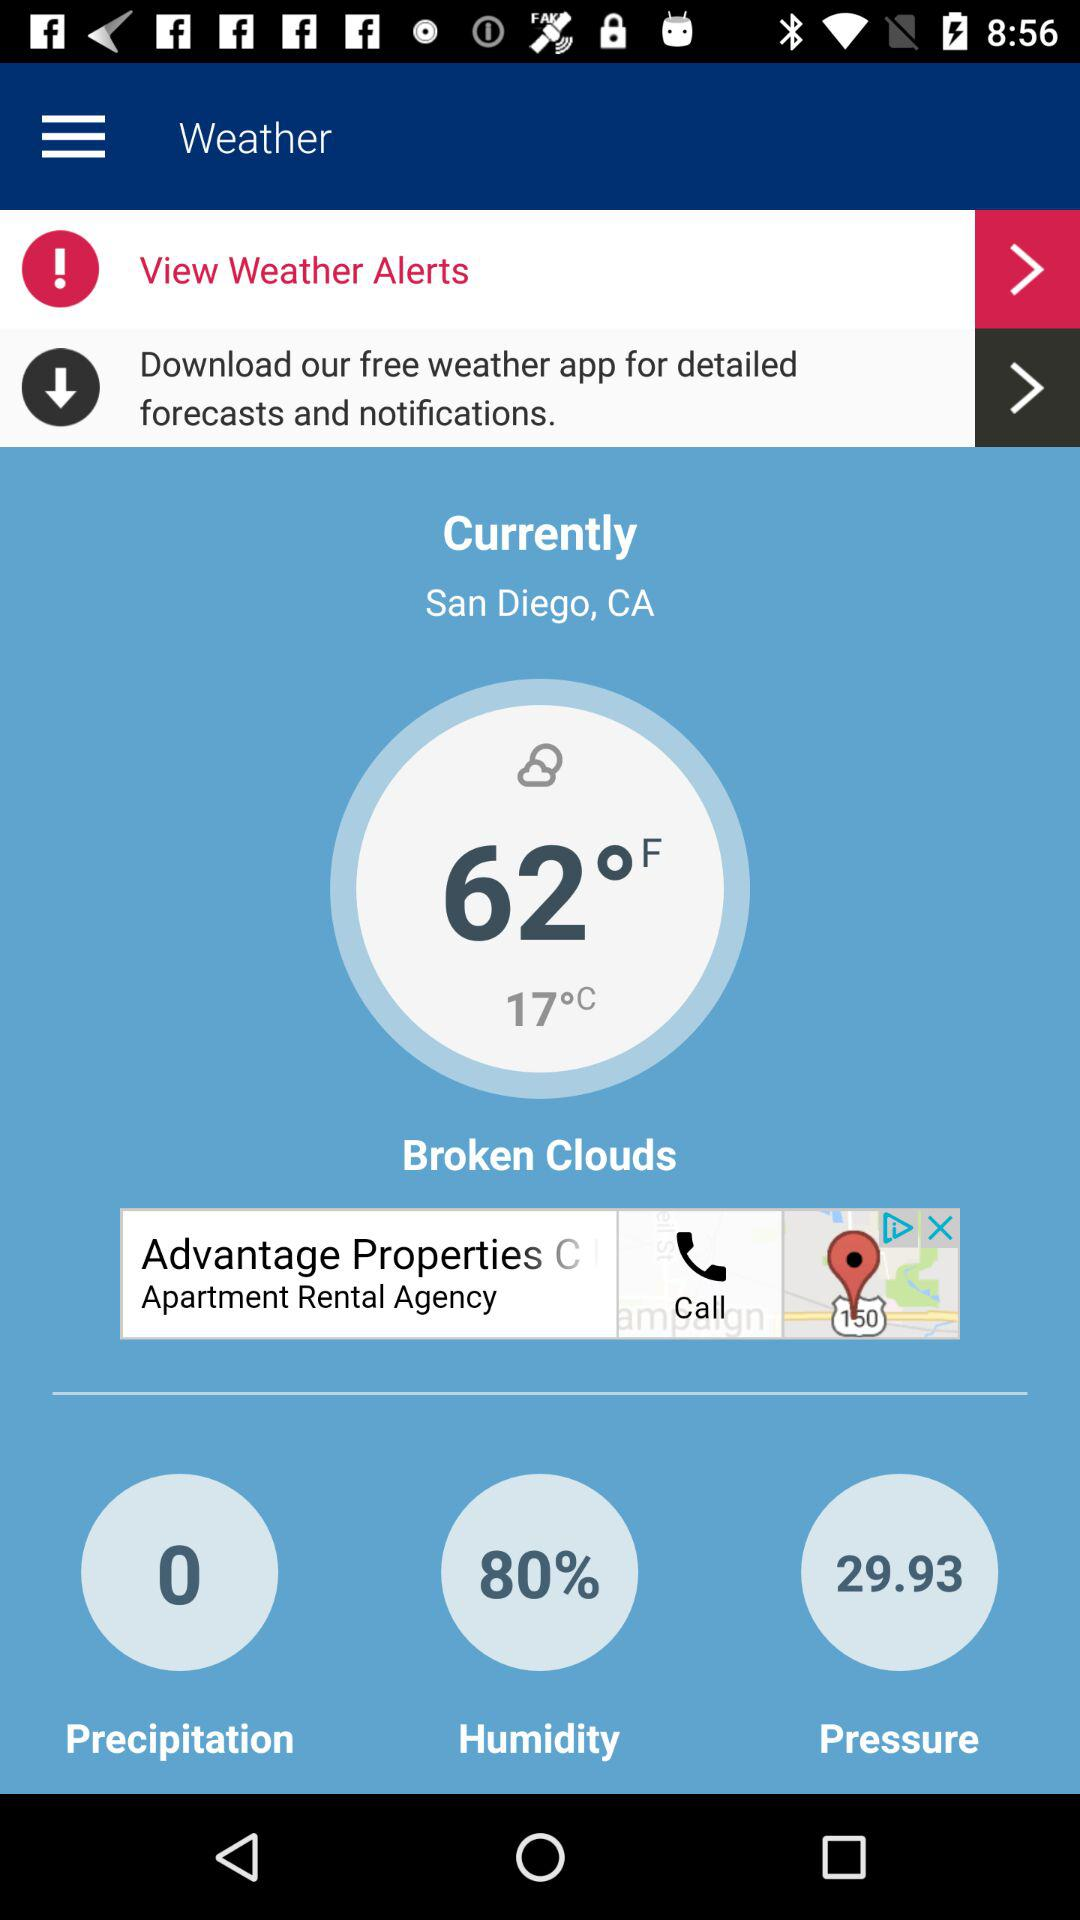How many degrees Fahrenheit is the temperature?
Answer the question using a single word or phrase. 62°F 